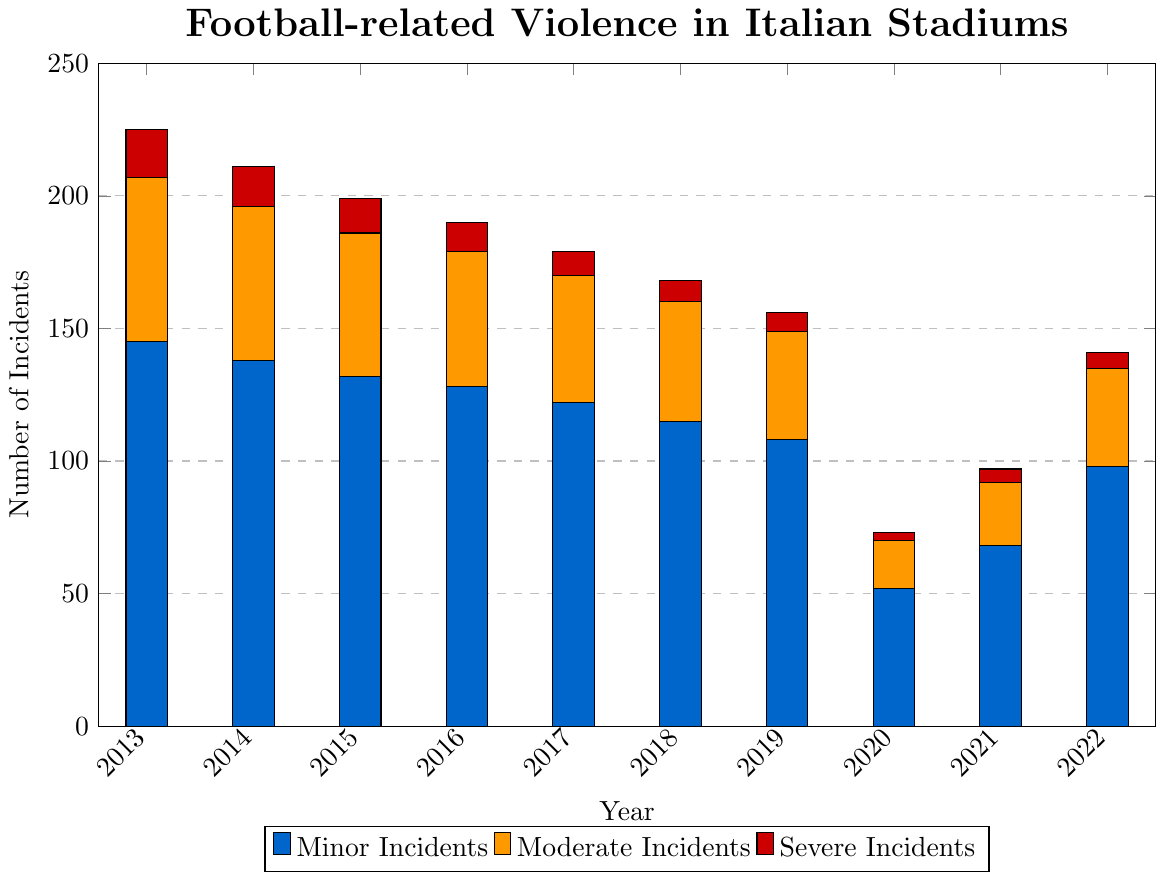What is the year with the highest number of minor incidents? To find the year with the highest number of minor incidents, look at the height of the blue bars across all years. The highest blue bar corresponds to the year 2013.
Answer: 2013 How many severe incidents were recorded in 2020? Find the height of the red bar for the year 2020. The red bar for 2020 corresponds to 3 severe incidents.
Answer: 3 What is the total number of incidents for the year 2017? Sum the minor, moderate, and severe incidents for 2017: 122 (minor) + 48 (moderate) + 9 (severe) = 179
Answer: 179 Which year experienced the lowest number of moderate incidents? Locate the orange bars and find the shortest one, which corresponds to the year 2020.
Answer: 2020 How did the number of minor incidents change from 2018 to 2019? Compare the height of the blue bars for 2018 and 2019. In 2018, there were 115 minor incidents, and in 2019, there were 108. The number dropped by 7 incidents.
Answer: Dropped by 7 What is the average number of severe incidents over the decade? Add the severe incidents for each year and divide by 10: (18+15+13+11+9+8+7+3+5+6)/10 = 95/10 = 9.5
Answer: 9.5 How many more minor incidents were there in 2022 compared to 2020? Subtract the minor incidents of 2020 from those of 2022: 98 - 52 = 46
Answer: 46 Which year saw a sudden decrease in all types of incidents compared to other years? By observing the bars for all incident types, it's clear that 2020 experienced a sudden decrease compared to previous years.
Answer: 2020 What is the trend in the number of total incidents from 2013 to 2019? Sum the incidents for each year and observe the trend: Total incidents decrease from 225 in 2013 to 156 in 2019, showing a downward trend.
Answer: Downward Which incident type saw the least variance over the years? Compare the variance in the heights of the blue, orange, and red bars. The red bars (severe incidents) show the least variance.
Answer: Severe incidents 